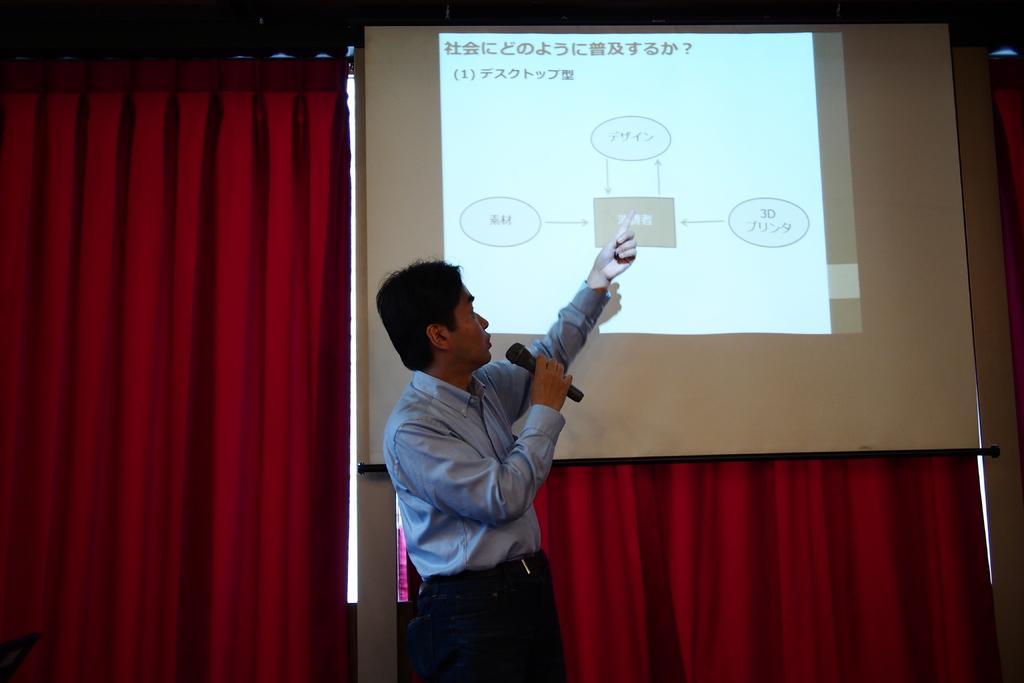How would you summarize this image in a sentence or two? There is one person standing and holding a Mic in the middle of this image, and there is a red color curtain in the background. There is a projector screen present at the top of this image. 